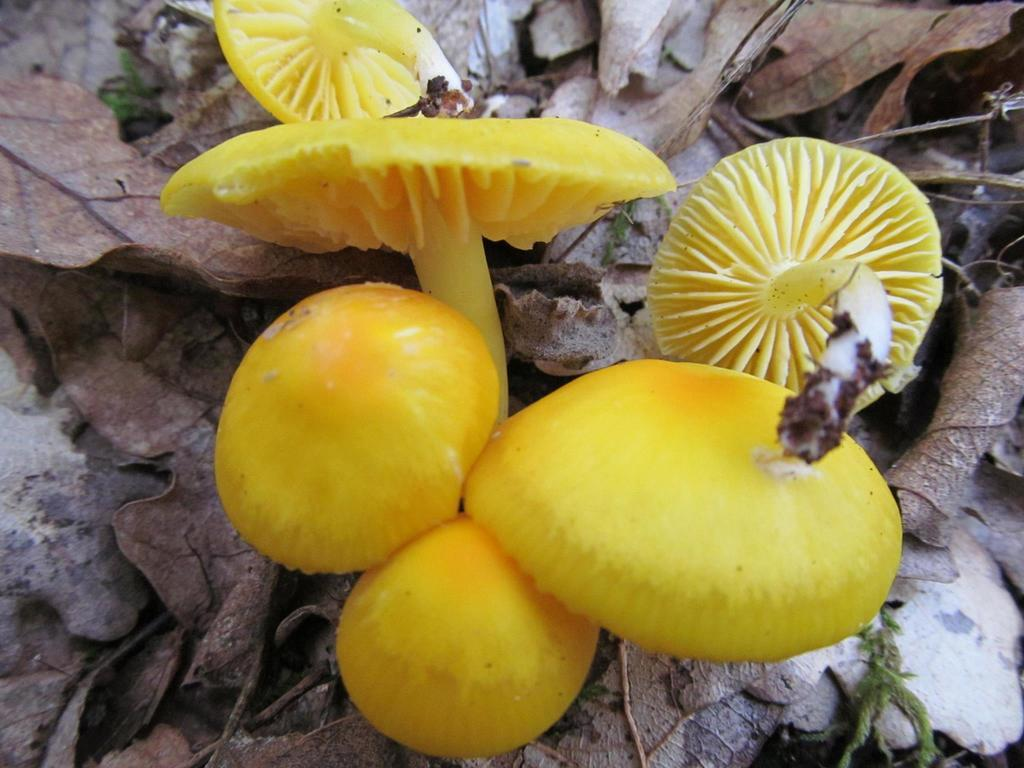What type of mushrooms can be seen in the image? There are yellow color mushrooms in the image. What type of vegetation can be seen in the image? There are dry leaves visible in the image. What type of advertisement can be seen on the mushrooms in the image? There is no advertisement present on the mushrooms in the image. 